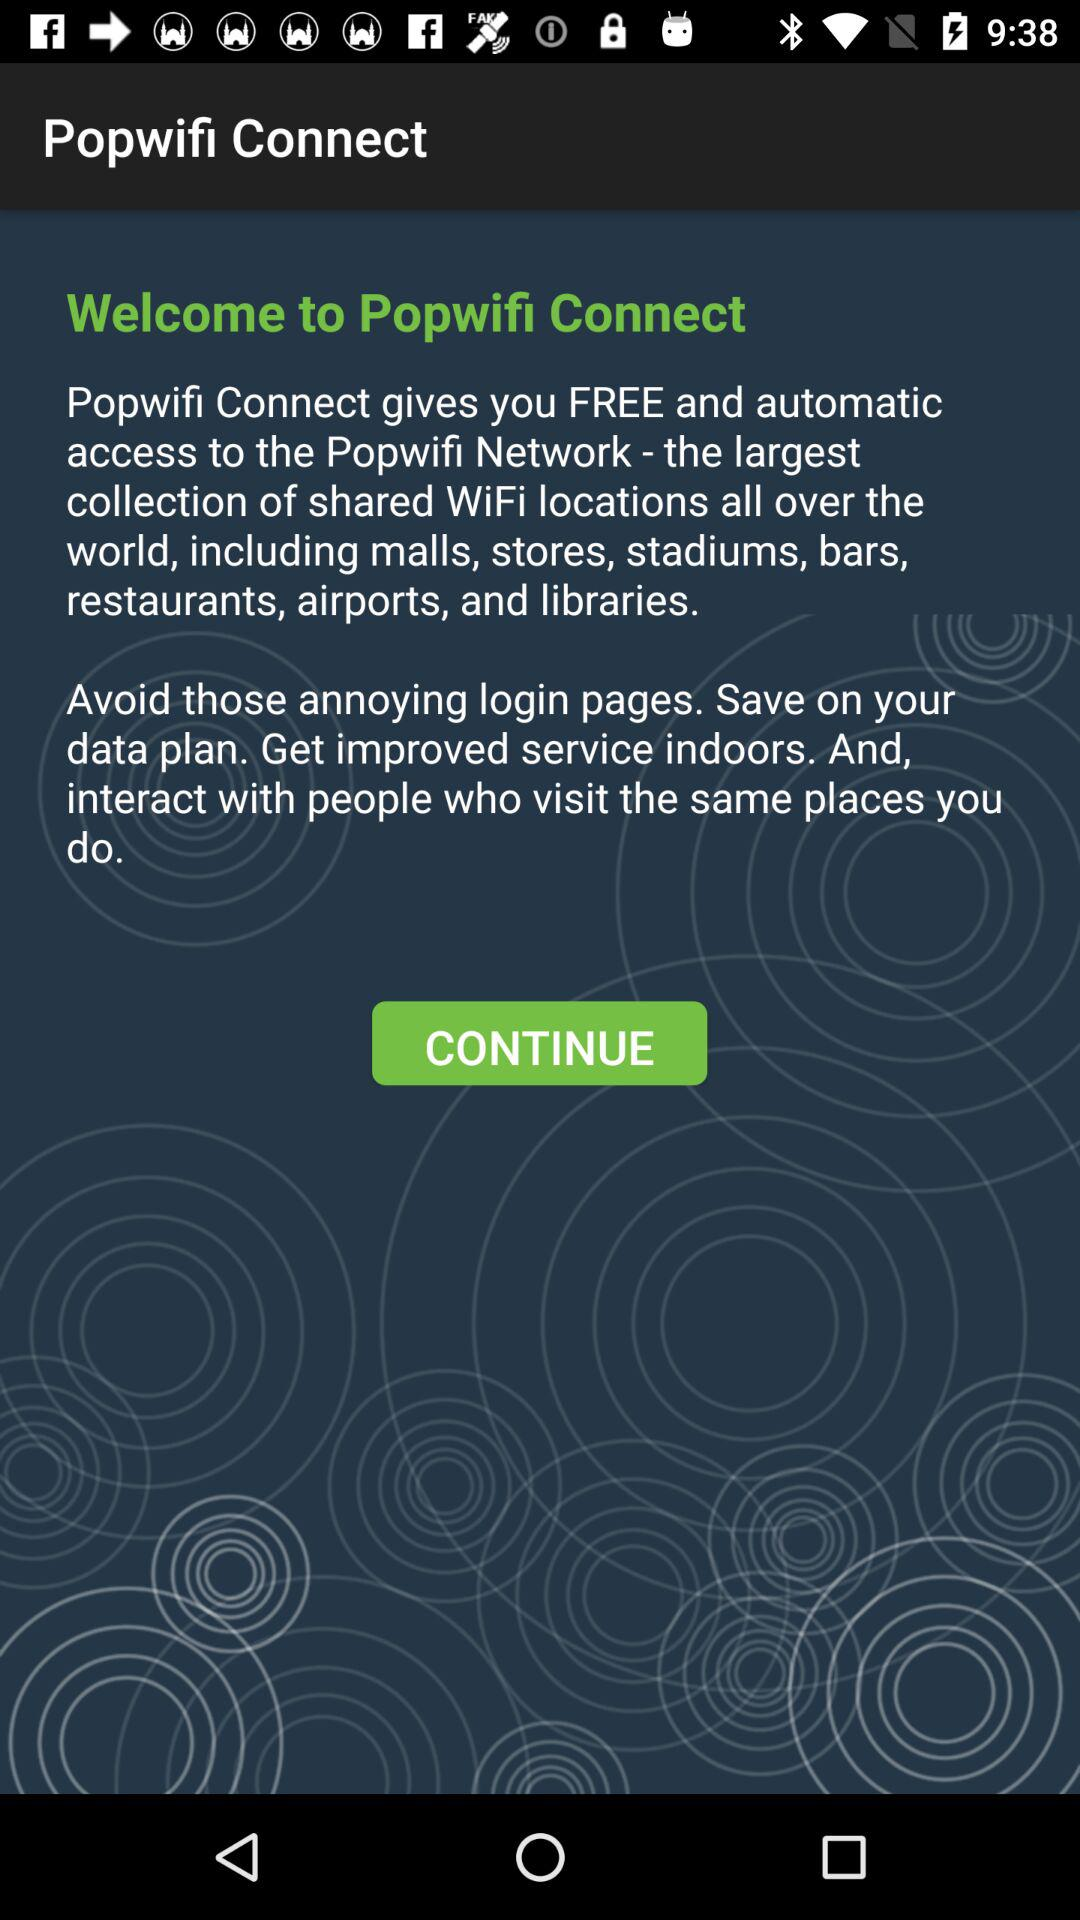Where is the nearest shared WiFi location?
When the provided information is insufficient, respond with <no answer>. <no answer> 